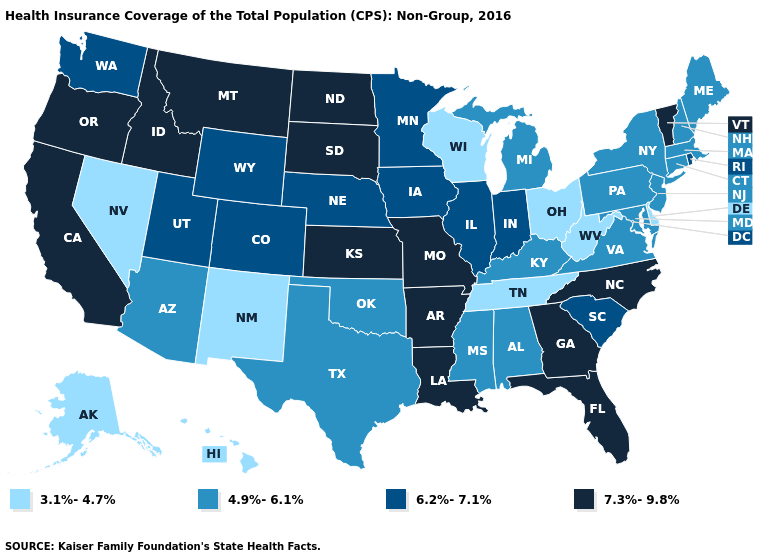Name the states that have a value in the range 6.2%-7.1%?
Answer briefly. Colorado, Illinois, Indiana, Iowa, Minnesota, Nebraska, Rhode Island, South Carolina, Utah, Washington, Wyoming. Name the states that have a value in the range 6.2%-7.1%?
Keep it brief. Colorado, Illinois, Indiana, Iowa, Minnesota, Nebraska, Rhode Island, South Carolina, Utah, Washington, Wyoming. What is the value of Georgia?
Give a very brief answer. 7.3%-9.8%. Does Michigan have the highest value in the MidWest?
Be succinct. No. Name the states that have a value in the range 4.9%-6.1%?
Write a very short answer. Alabama, Arizona, Connecticut, Kentucky, Maine, Maryland, Massachusetts, Michigan, Mississippi, New Hampshire, New Jersey, New York, Oklahoma, Pennsylvania, Texas, Virginia. What is the value of Iowa?
Write a very short answer. 6.2%-7.1%. Which states have the highest value in the USA?
Short answer required. Arkansas, California, Florida, Georgia, Idaho, Kansas, Louisiana, Missouri, Montana, North Carolina, North Dakota, Oregon, South Dakota, Vermont. Name the states that have a value in the range 4.9%-6.1%?
Be succinct. Alabama, Arizona, Connecticut, Kentucky, Maine, Maryland, Massachusetts, Michigan, Mississippi, New Hampshire, New Jersey, New York, Oklahoma, Pennsylvania, Texas, Virginia. What is the highest value in states that border Washington?
Answer briefly. 7.3%-9.8%. What is the value of Pennsylvania?
Quick response, please. 4.9%-6.1%. Does Illinois have a lower value than North Carolina?
Keep it brief. Yes. What is the value of Massachusetts?
Concise answer only. 4.9%-6.1%. What is the value of Texas?
Short answer required. 4.9%-6.1%. What is the value of Virginia?
Answer briefly. 4.9%-6.1%. What is the highest value in the South ?
Concise answer only. 7.3%-9.8%. 